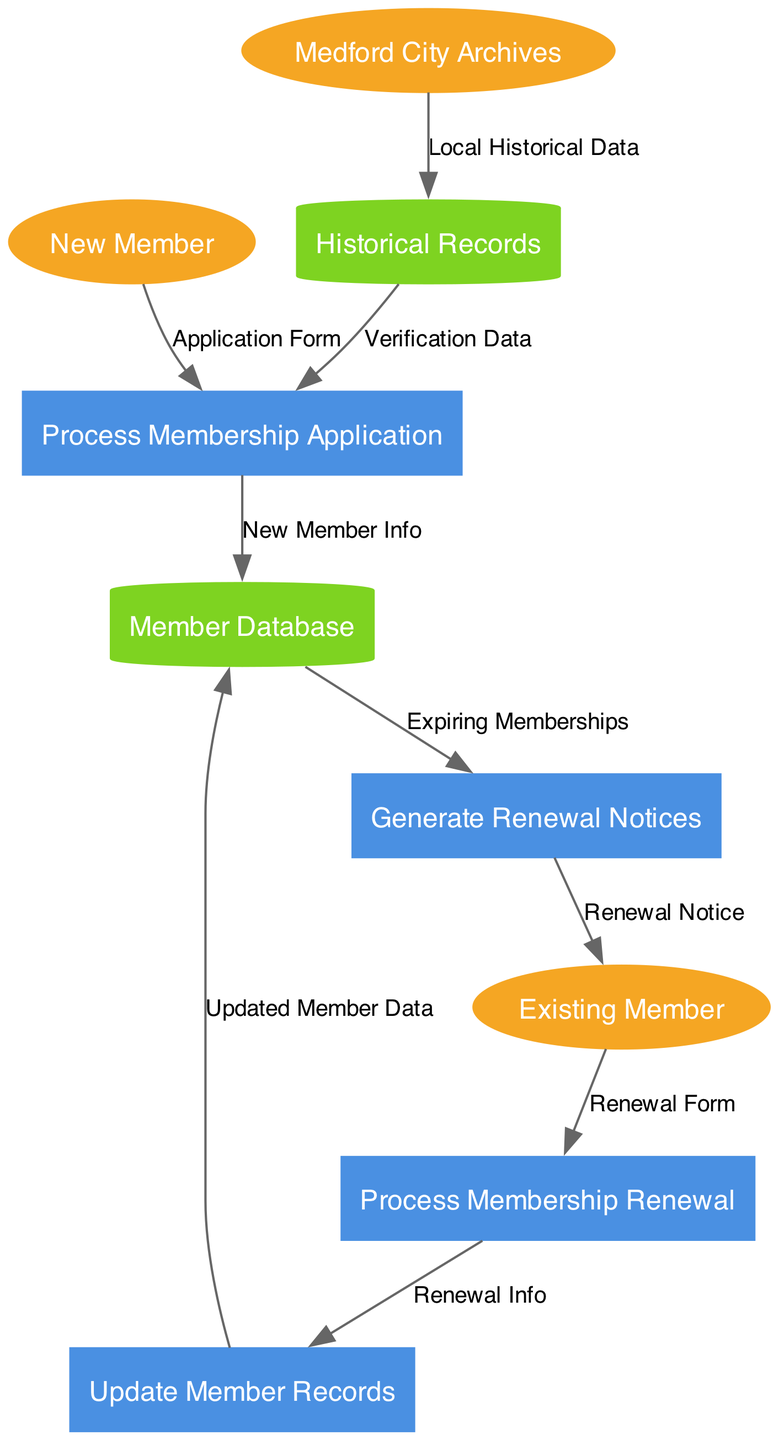What are the external entities involved in the membership system? The diagram lists three external entities: New Member, Existing Member, and Medford City Archives. These entities interact with the processes listed in the diagram.
Answer: New Member, Existing Member, Medford City Archives How many processes are represented in the diagram? The diagram includes four processes: Process Membership Application, Update Member Records, Generate Renewal Notices, and Process Membership Renewal. Adding these processes up provides the total.
Answer: 4 What data flow comes from New Member to the system? The data flow from New Member is labeled "Application Form" and it connects to the process called Process Membership Application. This describes how new members submit their applications.
Answer: Application Form Which process generates renewal notices? The process labeled Generate Renewal Notices is responsible for creating notices for existing members whose memberships are about to expire. It brings together data from the Member Database for this purpose.
Answer: Generate Renewal Notices What happens to the "Renewal Info" data? Renewal Info is directed from the Process Membership Renewal to Update Member Records, indicating that once the renewal is processed, the member records need to be updated with the new information.
Answer: Update Member Records What is the purpose of the data flow labeled "Verification Data"? Verification Data flows from Historical Records to the Process Membership Application, indicating that this data is used to verify the information provided in the membership applications.
Answer: Verification Data Which data store receives updated member data? The Member Database is the data store that receives Updated Member Data via the Update Member Records process. This illustrates where updated information about members is kept.
Answer: Member Database How does the system retrieve the list of expiring memberships? The Generate Renewal Notices process retrieves expiring memberships from the Member Database, using this information to generate renewal notices for existing members.
Answer: Generate Renewal Notices What type of diagram is this? The diagram is a Data Flow Diagram, which illustrates how data moves between external entities, processes, and data stores within the membership registration and renewal system.
Answer: Data Flow Diagram 